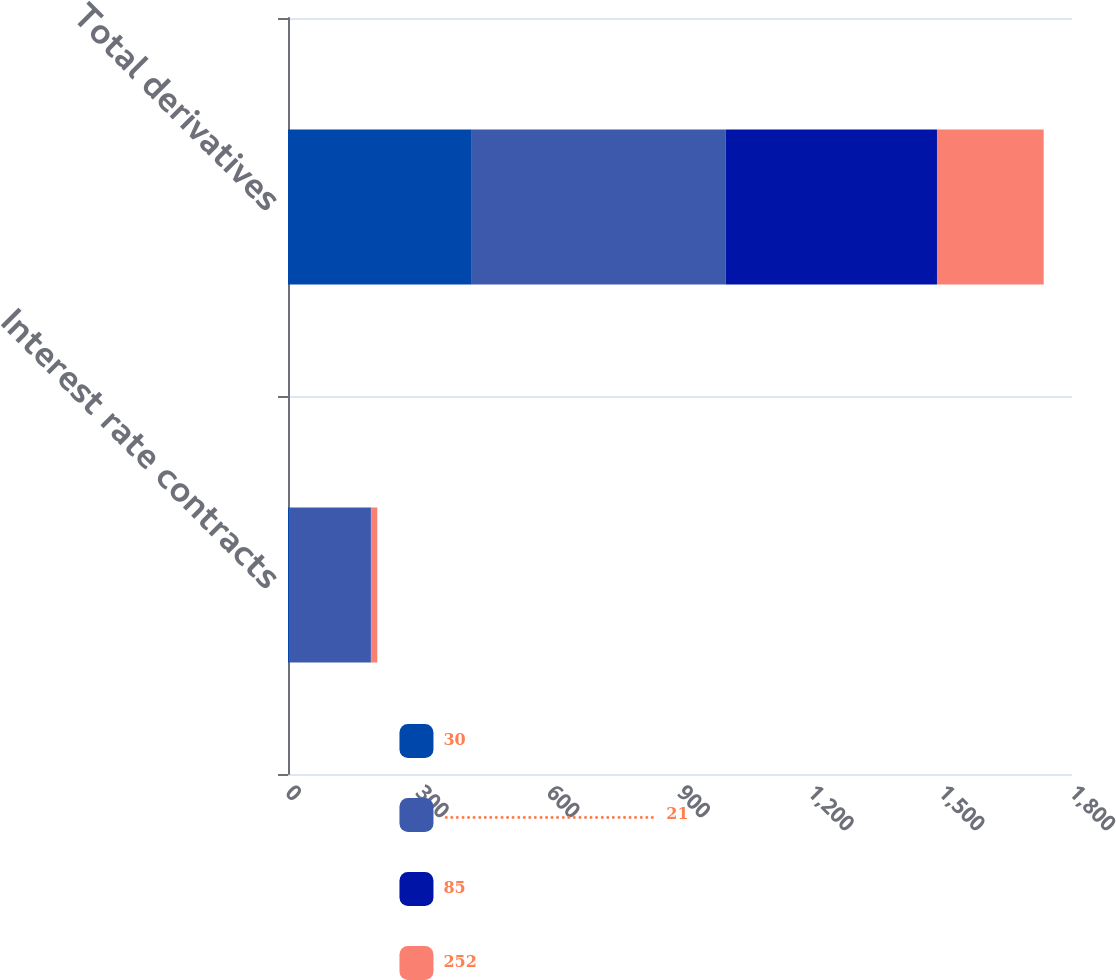<chart> <loc_0><loc_0><loc_500><loc_500><stacked_bar_chart><ecel><fcel>Interest rate contracts<fcel>Total derivatives<nl><fcel>30<fcel>3<fcel>422<nl><fcel>......................................  21<fcel>187<fcel>583<nl><fcel>85<fcel>1<fcel>485<nl><fcel>252<fcel>14<fcel>245<nl></chart> 